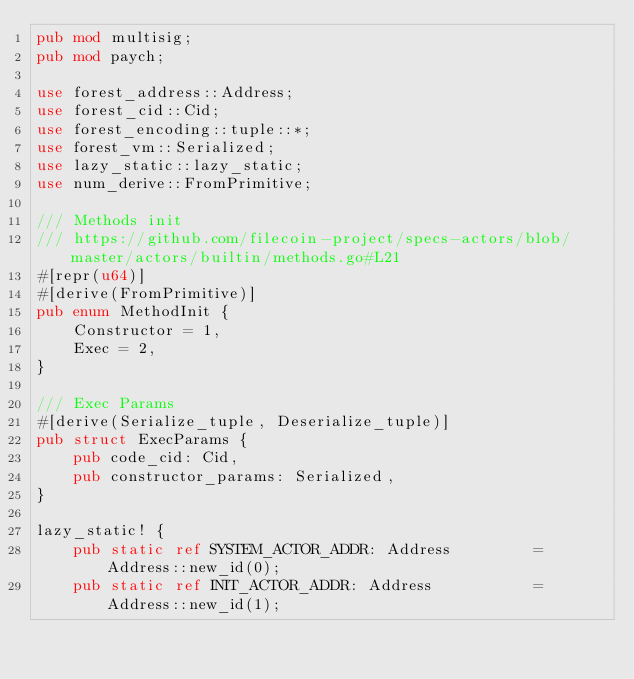Convert code to text. <code><loc_0><loc_0><loc_500><loc_500><_Rust_>pub mod multisig;
pub mod paych;

use forest_address::Address;
use forest_cid::Cid;
use forest_encoding::tuple::*;
use forest_vm::Serialized;
use lazy_static::lazy_static;
use num_derive::FromPrimitive;

/// Methods init
/// https://github.com/filecoin-project/specs-actors/blob/master/actors/builtin/methods.go#L21
#[repr(u64)]
#[derive(FromPrimitive)]
pub enum MethodInit {
    Constructor = 1,
    Exec = 2,
}

/// Exec Params
#[derive(Serialize_tuple, Deserialize_tuple)]
pub struct ExecParams {
    pub code_cid: Cid,
    pub constructor_params: Serialized,
}

lazy_static! {
    pub static ref SYSTEM_ACTOR_ADDR: Address         = Address::new_id(0);
    pub static ref INIT_ACTOR_ADDR: Address           = Address::new_id(1);</code> 